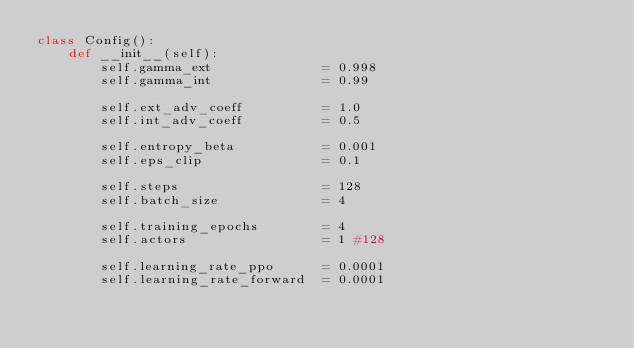<code> <loc_0><loc_0><loc_500><loc_500><_Python_>class Config(): 
    def __init__(self):
        self.gamma_ext              = 0.998
        self.gamma_int              = 0.99

        self.ext_adv_coeff          = 1.0
        self.int_adv_coeff          = 0.5

        self.entropy_beta           = 0.001
        self.eps_clip               = 0.1

        self.steps                  = 128
        self.batch_size             = 4
        
        self.training_epochs        = 4
        self.actors                 = 1 #128
        
        self.learning_rate_ppo      = 0.0001
        self.learning_rate_forward  = 0.0001
        
</code> 